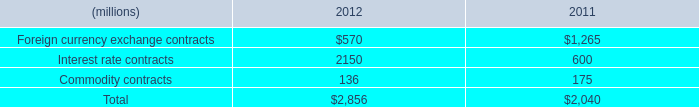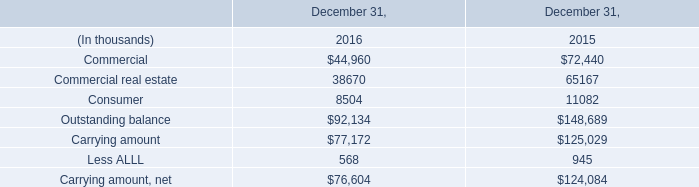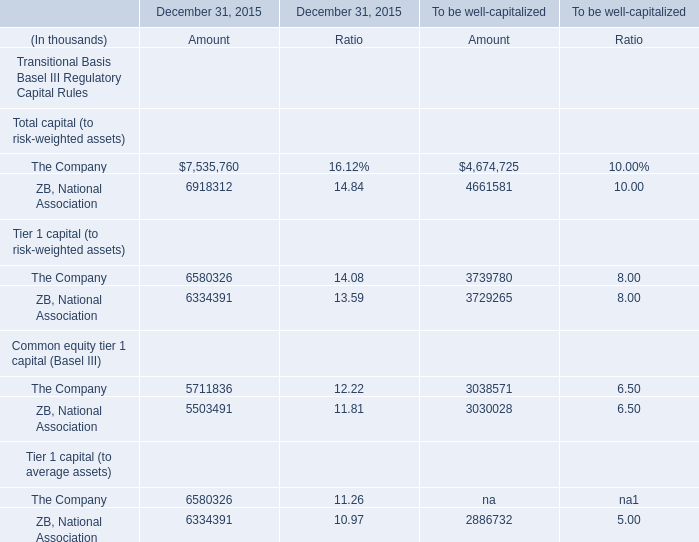what's the total amount of The Company of December 31, 2015 Amount, Commercial real estate of December 31, 2015, and ZB, National Association of December 31, 2015 Amount ? 
Computations: ((7535760.0 + 65167.0) + 6918312.0)
Answer: 14519239.0. 